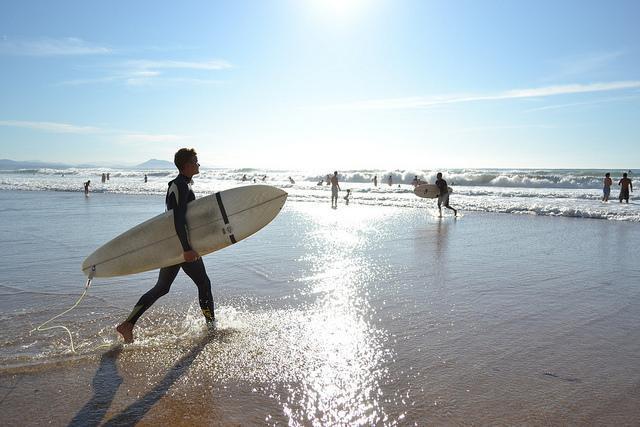What is the man walking to?
Answer the question by selecting the correct answer among the 4 following choices and explain your choice with a short sentence. The answer should be formatted with the following format: `Answer: choice
Rationale: rationale.`
Options: Ocean, pond, river, lake. Answer: ocean.
Rationale: He is trying to get into the water. 